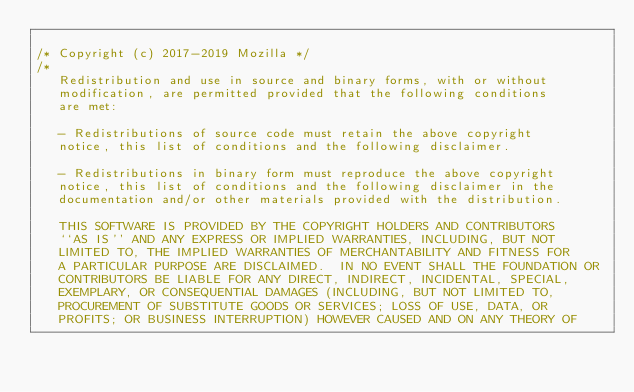<code> <loc_0><loc_0><loc_500><loc_500><_C_>
/* Copyright (c) 2017-2019 Mozilla */
/*
   Redistribution and use in source and binary forms, with or without
   modification, are permitted provided that the following conditions
   are met:

   - Redistributions of source code must retain the above copyright
   notice, this list of conditions and the following disclaimer.

   - Redistributions in binary form must reproduce the above copyright
   notice, this list of conditions and the following disclaimer in the
   documentation and/or other materials provided with the distribution.

   THIS SOFTWARE IS PROVIDED BY THE COPYRIGHT HOLDERS AND CONTRIBUTORS
   ``AS IS'' AND ANY EXPRESS OR IMPLIED WARRANTIES, INCLUDING, BUT NOT
   LIMITED TO, THE IMPLIED WARRANTIES OF MERCHANTABILITY AND FITNESS FOR
   A PARTICULAR PURPOSE ARE DISCLAIMED.  IN NO EVENT SHALL THE FOUNDATION OR
   CONTRIBUTORS BE LIABLE FOR ANY DIRECT, INDIRECT, INCIDENTAL, SPECIAL,
   EXEMPLARY, OR CONSEQUENTIAL DAMAGES (INCLUDING, BUT NOT LIMITED TO,
   PROCUREMENT OF SUBSTITUTE GOODS OR SERVICES; LOSS OF USE, DATA, OR
   PROFITS; OR BUSINESS INTERRUPTION) HOWEVER CAUSED AND ON ANY THEORY OF</code> 